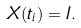Convert formula to latex. <formula><loc_0><loc_0><loc_500><loc_500>X ( t _ { i } ) = I .</formula> 